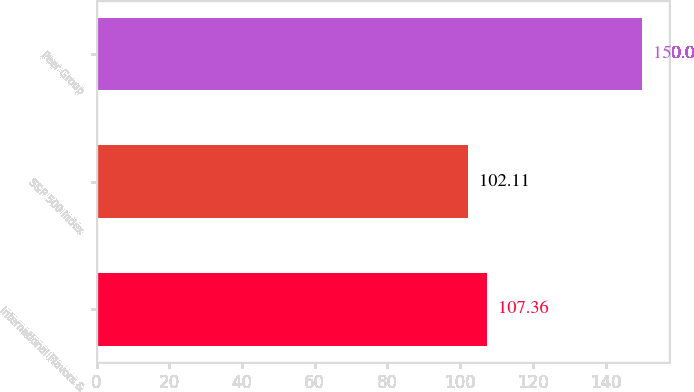Convert chart. <chart><loc_0><loc_0><loc_500><loc_500><bar_chart><fcel>International Flavors &<fcel>S&P 500 Index<fcel>Peer Group<nl><fcel>107.36<fcel>102.11<fcel>150<nl></chart> 